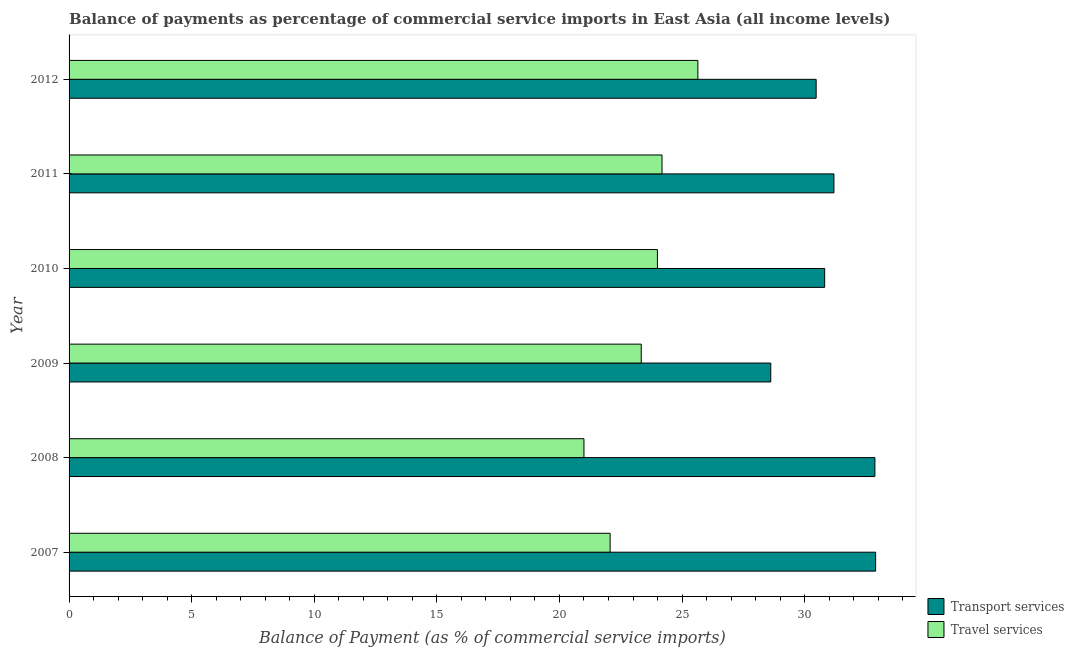How many bars are there on the 5th tick from the bottom?
Offer a very short reply. 2. What is the label of the 4th group of bars from the top?
Keep it short and to the point. 2009. What is the balance of payments of travel services in 2011?
Offer a very short reply. 24.18. Across all years, what is the maximum balance of payments of transport services?
Make the answer very short. 32.9. Across all years, what is the minimum balance of payments of transport services?
Your response must be concise. 28.62. In which year was the balance of payments of travel services minimum?
Your response must be concise. 2008. What is the total balance of payments of transport services in the graph?
Provide a short and direct response. 186.86. What is the difference between the balance of payments of transport services in 2010 and that in 2012?
Give a very brief answer. 0.35. What is the difference between the balance of payments of transport services in 2008 and the balance of payments of travel services in 2007?
Offer a very short reply. 10.8. What is the average balance of payments of travel services per year?
Keep it short and to the point. 23.37. In the year 2011, what is the difference between the balance of payments of transport services and balance of payments of travel services?
Provide a short and direct response. 7.01. What is the ratio of the balance of payments of travel services in 2008 to that in 2012?
Give a very brief answer. 0.82. Is the balance of payments of transport services in 2009 less than that in 2010?
Ensure brevity in your answer.  Yes. What is the difference between the highest and the second highest balance of payments of transport services?
Your response must be concise. 0.03. What is the difference between the highest and the lowest balance of payments of travel services?
Provide a short and direct response. 4.65. In how many years, is the balance of payments of travel services greater than the average balance of payments of travel services taken over all years?
Offer a terse response. 3. Is the sum of the balance of payments of transport services in 2007 and 2010 greater than the maximum balance of payments of travel services across all years?
Offer a terse response. Yes. What does the 1st bar from the top in 2012 represents?
Your response must be concise. Travel services. What does the 2nd bar from the bottom in 2008 represents?
Your answer should be compact. Travel services. Are all the bars in the graph horizontal?
Give a very brief answer. Yes. Does the graph contain grids?
Provide a succinct answer. No. How many legend labels are there?
Keep it short and to the point. 2. What is the title of the graph?
Your response must be concise. Balance of payments as percentage of commercial service imports in East Asia (all income levels). What is the label or title of the X-axis?
Provide a succinct answer. Balance of Payment (as % of commercial service imports). What is the Balance of Payment (as % of commercial service imports) of Transport services in 2007?
Your answer should be very brief. 32.9. What is the Balance of Payment (as % of commercial service imports) of Travel services in 2007?
Your answer should be compact. 22.07. What is the Balance of Payment (as % of commercial service imports) of Transport services in 2008?
Provide a succinct answer. 32.87. What is the Balance of Payment (as % of commercial service imports) in Travel services in 2008?
Ensure brevity in your answer.  21. What is the Balance of Payment (as % of commercial service imports) of Transport services in 2009?
Offer a terse response. 28.62. What is the Balance of Payment (as % of commercial service imports) of Travel services in 2009?
Provide a succinct answer. 23.34. What is the Balance of Payment (as % of commercial service imports) of Transport services in 2010?
Provide a succinct answer. 30.82. What is the Balance of Payment (as % of commercial service imports) in Travel services in 2010?
Your answer should be very brief. 24. What is the Balance of Payment (as % of commercial service imports) of Transport services in 2011?
Provide a short and direct response. 31.2. What is the Balance of Payment (as % of commercial service imports) in Travel services in 2011?
Your answer should be very brief. 24.18. What is the Balance of Payment (as % of commercial service imports) in Transport services in 2012?
Offer a terse response. 30.47. What is the Balance of Payment (as % of commercial service imports) of Travel services in 2012?
Provide a short and direct response. 25.65. Across all years, what is the maximum Balance of Payment (as % of commercial service imports) in Transport services?
Ensure brevity in your answer.  32.9. Across all years, what is the maximum Balance of Payment (as % of commercial service imports) of Travel services?
Ensure brevity in your answer.  25.65. Across all years, what is the minimum Balance of Payment (as % of commercial service imports) of Transport services?
Your answer should be very brief. 28.62. Across all years, what is the minimum Balance of Payment (as % of commercial service imports) of Travel services?
Offer a terse response. 21. What is the total Balance of Payment (as % of commercial service imports) in Transport services in the graph?
Give a very brief answer. 186.86. What is the total Balance of Payment (as % of commercial service imports) of Travel services in the graph?
Provide a short and direct response. 140.23. What is the difference between the Balance of Payment (as % of commercial service imports) of Transport services in 2007 and that in 2008?
Your answer should be very brief. 0.03. What is the difference between the Balance of Payment (as % of commercial service imports) of Travel services in 2007 and that in 2008?
Your answer should be compact. 1.07. What is the difference between the Balance of Payment (as % of commercial service imports) in Transport services in 2007 and that in 2009?
Provide a succinct answer. 4.28. What is the difference between the Balance of Payment (as % of commercial service imports) in Travel services in 2007 and that in 2009?
Provide a short and direct response. -1.27. What is the difference between the Balance of Payment (as % of commercial service imports) in Transport services in 2007 and that in 2010?
Offer a terse response. 2.08. What is the difference between the Balance of Payment (as % of commercial service imports) of Travel services in 2007 and that in 2010?
Your answer should be very brief. -1.93. What is the difference between the Balance of Payment (as % of commercial service imports) of Transport services in 2007 and that in 2011?
Offer a very short reply. 1.7. What is the difference between the Balance of Payment (as % of commercial service imports) in Travel services in 2007 and that in 2011?
Give a very brief answer. -2.12. What is the difference between the Balance of Payment (as % of commercial service imports) of Transport services in 2007 and that in 2012?
Provide a short and direct response. 2.42. What is the difference between the Balance of Payment (as % of commercial service imports) in Travel services in 2007 and that in 2012?
Your answer should be very brief. -3.58. What is the difference between the Balance of Payment (as % of commercial service imports) of Transport services in 2008 and that in 2009?
Offer a terse response. 4.25. What is the difference between the Balance of Payment (as % of commercial service imports) of Travel services in 2008 and that in 2009?
Keep it short and to the point. -2.34. What is the difference between the Balance of Payment (as % of commercial service imports) in Transport services in 2008 and that in 2010?
Offer a very short reply. 2.05. What is the difference between the Balance of Payment (as % of commercial service imports) of Travel services in 2008 and that in 2010?
Provide a succinct answer. -3. What is the difference between the Balance of Payment (as % of commercial service imports) in Transport services in 2008 and that in 2011?
Provide a succinct answer. 1.67. What is the difference between the Balance of Payment (as % of commercial service imports) of Travel services in 2008 and that in 2011?
Your answer should be compact. -3.18. What is the difference between the Balance of Payment (as % of commercial service imports) in Transport services in 2008 and that in 2012?
Provide a succinct answer. 2.4. What is the difference between the Balance of Payment (as % of commercial service imports) in Travel services in 2008 and that in 2012?
Offer a terse response. -4.65. What is the difference between the Balance of Payment (as % of commercial service imports) of Transport services in 2009 and that in 2010?
Offer a very short reply. -2.2. What is the difference between the Balance of Payment (as % of commercial service imports) of Travel services in 2009 and that in 2010?
Your answer should be compact. -0.66. What is the difference between the Balance of Payment (as % of commercial service imports) of Transport services in 2009 and that in 2011?
Your response must be concise. -2.58. What is the difference between the Balance of Payment (as % of commercial service imports) of Travel services in 2009 and that in 2011?
Provide a succinct answer. -0.85. What is the difference between the Balance of Payment (as % of commercial service imports) in Transport services in 2009 and that in 2012?
Make the answer very short. -1.85. What is the difference between the Balance of Payment (as % of commercial service imports) of Travel services in 2009 and that in 2012?
Give a very brief answer. -2.31. What is the difference between the Balance of Payment (as % of commercial service imports) in Transport services in 2010 and that in 2011?
Give a very brief answer. -0.38. What is the difference between the Balance of Payment (as % of commercial service imports) of Travel services in 2010 and that in 2011?
Provide a succinct answer. -0.19. What is the difference between the Balance of Payment (as % of commercial service imports) in Transport services in 2010 and that in 2012?
Offer a very short reply. 0.35. What is the difference between the Balance of Payment (as % of commercial service imports) in Travel services in 2010 and that in 2012?
Offer a terse response. -1.65. What is the difference between the Balance of Payment (as % of commercial service imports) in Transport services in 2011 and that in 2012?
Offer a very short reply. 0.72. What is the difference between the Balance of Payment (as % of commercial service imports) of Travel services in 2011 and that in 2012?
Give a very brief answer. -1.46. What is the difference between the Balance of Payment (as % of commercial service imports) of Transport services in 2007 and the Balance of Payment (as % of commercial service imports) of Travel services in 2008?
Give a very brief answer. 11.9. What is the difference between the Balance of Payment (as % of commercial service imports) in Transport services in 2007 and the Balance of Payment (as % of commercial service imports) in Travel services in 2009?
Give a very brief answer. 9.56. What is the difference between the Balance of Payment (as % of commercial service imports) in Transport services in 2007 and the Balance of Payment (as % of commercial service imports) in Travel services in 2010?
Provide a succinct answer. 8.9. What is the difference between the Balance of Payment (as % of commercial service imports) in Transport services in 2007 and the Balance of Payment (as % of commercial service imports) in Travel services in 2011?
Keep it short and to the point. 8.71. What is the difference between the Balance of Payment (as % of commercial service imports) of Transport services in 2007 and the Balance of Payment (as % of commercial service imports) of Travel services in 2012?
Give a very brief answer. 7.25. What is the difference between the Balance of Payment (as % of commercial service imports) in Transport services in 2008 and the Balance of Payment (as % of commercial service imports) in Travel services in 2009?
Ensure brevity in your answer.  9.53. What is the difference between the Balance of Payment (as % of commercial service imports) in Transport services in 2008 and the Balance of Payment (as % of commercial service imports) in Travel services in 2010?
Offer a very short reply. 8.87. What is the difference between the Balance of Payment (as % of commercial service imports) in Transport services in 2008 and the Balance of Payment (as % of commercial service imports) in Travel services in 2011?
Offer a very short reply. 8.68. What is the difference between the Balance of Payment (as % of commercial service imports) of Transport services in 2008 and the Balance of Payment (as % of commercial service imports) of Travel services in 2012?
Ensure brevity in your answer.  7.22. What is the difference between the Balance of Payment (as % of commercial service imports) of Transport services in 2009 and the Balance of Payment (as % of commercial service imports) of Travel services in 2010?
Offer a very short reply. 4.62. What is the difference between the Balance of Payment (as % of commercial service imports) of Transport services in 2009 and the Balance of Payment (as % of commercial service imports) of Travel services in 2011?
Ensure brevity in your answer.  4.43. What is the difference between the Balance of Payment (as % of commercial service imports) of Transport services in 2009 and the Balance of Payment (as % of commercial service imports) of Travel services in 2012?
Offer a very short reply. 2.97. What is the difference between the Balance of Payment (as % of commercial service imports) in Transport services in 2010 and the Balance of Payment (as % of commercial service imports) in Travel services in 2011?
Your answer should be very brief. 6.63. What is the difference between the Balance of Payment (as % of commercial service imports) in Transport services in 2010 and the Balance of Payment (as % of commercial service imports) in Travel services in 2012?
Make the answer very short. 5.17. What is the difference between the Balance of Payment (as % of commercial service imports) in Transport services in 2011 and the Balance of Payment (as % of commercial service imports) in Travel services in 2012?
Your response must be concise. 5.55. What is the average Balance of Payment (as % of commercial service imports) of Transport services per year?
Make the answer very short. 31.14. What is the average Balance of Payment (as % of commercial service imports) in Travel services per year?
Give a very brief answer. 23.37. In the year 2007, what is the difference between the Balance of Payment (as % of commercial service imports) in Transport services and Balance of Payment (as % of commercial service imports) in Travel services?
Your answer should be compact. 10.83. In the year 2008, what is the difference between the Balance of Payment (as % of commercial service imports) of Transport services and Balance of Payment (as % of commercial service imports) of Travel services?
Ensure brevity in your answer.  11.87. In the year 2009, what is the difference between the Balance of Payment (as % of commercial service imports) of Transport services and Balance of Payment (as % of commercial service imports) of Travel services?
Give a very brief answer. 5.28. In the year 2010, what is the difference between the Balance of Payment (as % of commercial service imports) in Transport services and Balance of Payment (as % of commercial service imports) in Travel services?
Your answer should be compact. 6.82. In the year 2011, what is the difference between the Balance of Payment (as % of commercial service imports) of Transport services and Balance of Payment (as % of commercial service imports) of Travel services?
Ensure brevity in your answer.  7.01. In the year 2012, what is the difference between the Balance of Payment (as % of commercial service imports) in Transport services and Balance of Payment (as % of commercial service imports) in Travel services?
Give a very brief answer. 4.83. What is the ratio of the Balance of Payment (as % of commercial service imports) of Travel services in 2007 to that in 2008?
Give a very brief answer. 1.05. What is the ratio of the Balance of Payment (as % of commercial service imports) of Transport services in 2007 to that in 2009?
Provide a succinct answer. 1.15. What is the ratio of the Balance of Payment (as % of commercial service imports) in Travel services in 2007 to that in 2009?
Make the answer very short. 0.95. What is the ratio of the Balance of Payment (as % of commercial service imports) in Transport services in 2007 to that in 2010?
Give a very brief answer. 1.07. What is the ratio of the Balance of Payment (as % of commercial service imports) of Travel services in 2007 to that in 2010?
Make the answer very short. 0.92. What is the ratio of the Balance of Payment (as % of commercial service imports) in Transport services in 2007 to that in 2011?
Keep it short and to the point. 1.05. What is the ratio of the Balance of Payment (as % of commercial service imports) in Travel services in 2007 to that in 2011?
Make the answer very short. 0.91. What is the ratio of the Balance of Payment (as % of commercial service imports) of Transport services in 2007 to that in 2012?
Your response must be concise. 1.08. What is the ratio of the Balance of Payment (as % of commercial service imports) in Travel services in 2007 to that in 2012?
Make the answer very short. 0.86. What is the ratio of the Balance of Payment (as % of commercial service imports) of Transport services in 2008 to that in 2009?
Keep it short and to the point. 1.15. What is the ratio of the Balance of Payment (as % of commercial service imports) in Travel services in 2008 to that in 2009?
Your response must be concise. 0.9. What is the ratio of the Balance of Payment (as % of commercial service imports) of Transport services in 2008 to that in 2010?
Your answer should be compact. 1.07. What is the ratio of the Balance of Payment (as % of commercial service imports) in Travel services in 2008 to that in 2010?
Ensure brevity in your answer.  0.88. What is the ratio of the Balance of Payment (as % of commercial service imports) of Transport services in 2008 to that in 2011?
Offer a very short reply. 1.05. What is the ratio of the Balance of Payment (as % of commercial service imports) in Travel services in 2008 to that in 2011?
Offer a terse response. 0.87. What is the ratio of the Balance of Payment (as % of commercial service imports) of Transport services in 2008 to that in 2012?
Ensure brevity in your answer.  1.08. What is the ratio of the Balance of Payment (as % of commercial service imports) in Travel services in 2008 to that in 2012?
Offer a terse response. 0.82. What is the ratio of the Balance of Payment (as % of commercial service imports) of Transport services in 2009 to that in 2010?
Your answer should be compact. 0.93. What is the ratio of the Balance of Payment (as % of commercial service imports) in Travel services in 2009 to that in 2010?
Offer a terse response. 0.97. What is the ratio of the Balance of Payment (as % of commercial service imports) of Transport services in 2009 to that in 2011?
Ensure brevity in your answer.  0.92. What is the ratio of the Balance of Payment (as % of commercial service imports) of Travel services in 2009 to that in 2011?
Provide a succinct answer. 0.96. What is the ratio of the Balance of Payment (as % of commercial service imports) in Transport services in 2009 to that in 2012?
Your answer should be very brief. 0.94. What is the ratio of the Balance of Payment (as % of commercial service imports) of Travel services in 2009 to that in 2012?
Make the answer very short. 0.91. What is the ratio of the Balance of Payment (as % of commercial service imports) in Transport services in 2010 to that in 2011?
Offer a terse response. 0.99. What is the ratio of the Balance of Payment (as % of commercial service imports) of Transport services in 2010 to that in 2012?
Your response must be concise. 1.01. What is the ratio of the Balance of Payment (as % of commercial service imports) of Travel services in 2010 to that in 2012?
Give a very brief answer. 0.94. What is the ratio of the Balance of Payment (as % of commercial service imports) of Transport services in 2011 to that in 2012?
Provide a short and direct response. 1.02. What is the ratio of the Balance of Payment (as % of commercial service imports) of Travel services in 2011 to that in 2012?
Offer a very short reply. 0.94. What is the difference between the highest and the second highest Balance of Payment (as % of commercial service imports) in Transport services?
Your answer should be compact. 0.03. What is the difference between the highest and the second highest Balance of Payment (as % of commercial service imports) in Travel services?
Ensure brevity in your answer.  1.46. What is the difference between the highest and the lowest Balance of Payment (as % of commercial service imports) in Transport services?
Keep it short and to the point. 4.28. What is the difference between the highest and the lowest Balance of Payment (as % of commercial service imports) in Travel services?
Your response must be concise. 4.65. 